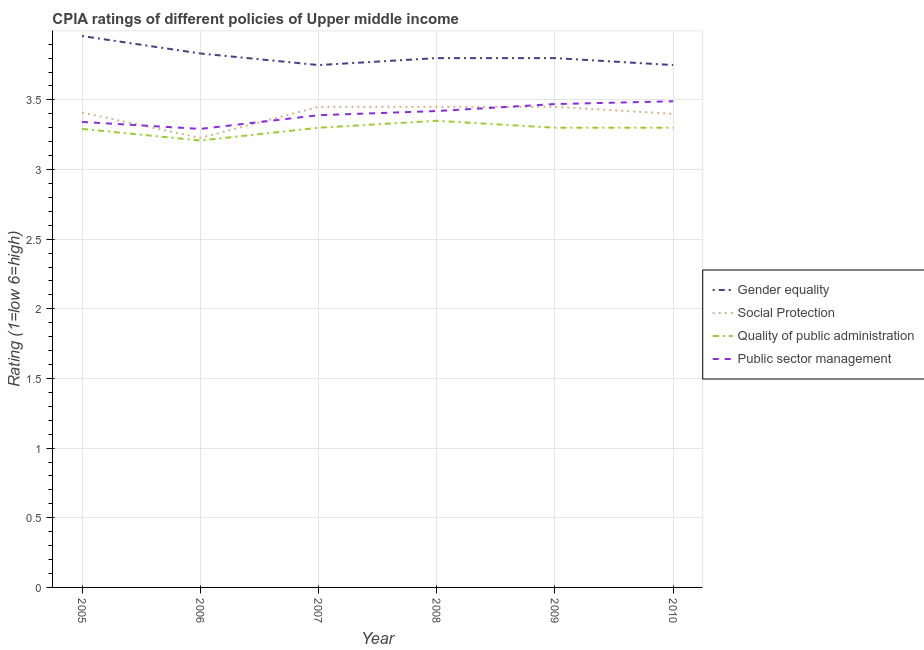Does the line corresponding to cpia rating of quality of public administration intersect with the line corresponding to cpia rating of gender equality?
Offer a terse response. No. What is the cpia rating of public sector management in 2007?
Provide a short and direct response. 3.39. Across all years, what is the maximum cpia rating of public sector management?
Your response must be concise. 3.49. Across all years, what is the minimum cpia rating of public sector management?
Give a very brief answer. 3.29. In which year was the cpia rating of quality of public administration maximum?
Your response must be concise. 2008. What is the total cpia rating of social protection in the graph?
Your response must be concise. 20.39. What is the difference between the cpia rating of gender equality in 2007 and the cpia rating of public sector management in 2006?
Your answer should be compact. 0.46. What is the average cpia rating of gender equality per year?
Provide a succinct answer. 3.82. In the year 2005, what is the difference between the cpia rating of gender equality and cpia rating of public sector management?
Provide a short and direct response. 0.62. In how many years, is the cpia rating of quality of public administration greater than 1.4?
Ensure brevity in your answer.  6. What is the ratio of the cpia rating of gender equality in 2005 to that in 2006?
Offer a terse response. 1.03. Is the cpia rating of gender equality in 2006 less than that in 2009?
Provide a short and direct response. No. Is the difference between the cpia rating of gender equality in 2006 and 2010 greater than the difference between the cpia rating of quality of public administration in 2006 and 2010?
Your answer should be very brief. Yes. What is the difference between the highest and the second highest cpia rating of gender equality?
Your response must be concise. 0.12. What is the difference between the highest and the lowest cpia rating of gender equality?
Keep it short and to the point. 0.21. In how many years, is the cpia rating of quality of public administration greater than the average cpia rating of quality of public administration taken over all years?
Keep it short and to the point. 5. Is the sum of the cpia rating of public sector management in 2005 and 2007 greater than the maximum cpia rating of quality of public administration across all years?
Your answer should be very brief. Yes. Is it the case that in every year, the sum of the cpia rating of gender equality and cpia rating of social protection is greater than the cpia rating of quality of public administration?
Keep it short and to the point. Yes. Is the cpia rating of public sector management strictly less than the cpia rating of quality of public administration over the years?
Ensure brevity in your answer.  No. Are the values on the major ticks of Y-axis written in scientific E-notation?
Offer a very short reply. No. Does the graph contain grids?
Provide a succinct answer. Yes. What is the title of the graph?
Make the answer very short. CPIA ratings of different policies of Upper middle income. Does "Natural Gas" appear as one of the legend labels in the graph?
Provide a short and direct response. No. What is the Rating (1=low 6=high) of Gender equality in 2005?
Give a very brief answer. 3.96. What is the Rating (1=low 6=high) of Social Protection in 2005?
Keep it short and to the point. 3.41. What is the Rating (1=low 6=high) of Quality of public administration in 2005?
Provide a short and direct response. 3.29. What is the Rating (1=low 6=high) of Public sector management in 2005?
Your response must be concise. 3.34. What is the Rating (1=low 6=high) in Gender equality in 2006?
Your answer should be compact. 3.83. What is the Rating (1=low 6=high) in Social Protection in 2006?
Give a very brief answer. 3.23. What is the Rating (1=low 6=high) of Quality of public administration in 2006?
Make the answer very short. 3.21. What is the Rating (1=low 6=high) in Public sector management in 2006?
Keep it short and to the point. 3.29. What is the Rating (1=low 6=high) in Gender equality in 2007?
Your response must be concise. 3.75. What is the Rating (1=low 6=high) of Social Protection in 2007?
Your answer should be compact. 3.45. What is the Rating (1=low 6=high) in Public sector management in 2007?
Make the answer very short. 3.39. What is the Rating (1=low 6=high) of Social Protection in 2008?
Offer a very short reply. 3.45. What is the Rating (1=low 6=high) of Quality of public administration in 2008?
Keep it short and to the point. 3.35. What is the Rating (1=low 6=high) of Public sector management in 2008?
Your response must be concise. 3.42. What is the Rating (1=low 6=high) of Social Protection in 2009?
Offer a terse response. 3.45. What is the Rating (1=low 6=high) in Quality of public administration in 2009?
Ensure brevity in your answer.  3.3. What is the Rating (1=low 6=high) of Public sector management in 2009?
Provide a short and direct response. 3.47. What is the Rating (1=low 6=high) of Gender equality in 2010?
Provide a short and direct response. 3.75. What is the Rating (1=low 6=high) in Social Protection in 2010?
Your answer should be compact. 3.4. What is the Rating (1=low 6=high) of Public sector management in 2010?
Your answer should be very brief. 3.49. Across all years, what is the maximum Rating (1=low 6=high) of Gender equality?
Offer a terse response. 3.96. Across all years, what is the maximum Rating (1=low 6=high) of Social Protection?
Make the answer very short. 3.45. Across all years, what is the maximum Rating (1=low 6=high) in Quality of public administration?
Offer a very short reply. 3.35. Across all years, what is the maximum Rating (1=low 6=high) in Public sector management?
Make the answer very short. 3.49. Across all years, what is the minimum Rating (1=low 6=high) of Gender equality?
Your answer should be very brief. 3.75. Across all years, what is the minimum Rating (1=low 6=high) of Social Protection?
Keep it short and to the point. 3.23. Across all years, what is the minimum Rating (1=low 6=high) in Quality of public administration?
Make the answer very short. 3.21. Across all years, what is the minimum Rating (1=low 6=high) of Public sector management?
Give a very brief answer. 3.29. What is the total Rating (1=low 6=high) in Gender equality in the graph?
Make the answer very short. 22.89. What is the total Rating (1=low 6=high) of Social Protection in the graph?
Ensure brevity in your answer.  20.39. What is the total Rating (1=low 6=high) in Quality of public administration in the graph?
Provide a succinct answer. 19.75. What is the total Rating (1=low 6=high) of Public sector management in the graph?
Your response must be concise. 20.4. What is the difference between the Rating (1=low 6=high) of Social Protection in 2005 and that in 2006?
Offer a terse response. 0.18. What is the difference between the Rating (1=low 6=high) of Quality of public administration in 2005 and that in 2006?
Provide a short and direct response. 0.08. What is the difference between the Rating (1=low 6=high) of Gender equality in 2005 and that in 2007?
Provide a short and direct response. 0.21. What is the difference between the Rating (1=low 6=high) in Social Protection in 2005 and that in 2007?
Provide a succinct answer. -0.04. What is the difference between the Rating (1=low 6=high) of Quality of public administration in 2005 and that in 2007?
Provide a succinct answer. -0.01. What is the difference between the Rating (1=low 6=high) of Public sector management in 2005 and that in 2007?
Make the answer very short. -0.05. What is the difference between the Rating (1=low 6=high) of Gender equality in 2005 and that in 2008?
Provide a succinct answer. 0.16. What is the difference between the Rating (1=low 6=high) of Social Protection in 2005 and that in 2008?
Make the answer very short. -0.04. What is the difference between the Rating (1=low 6=high) of Quality of public administration in 2005 and that in 2008?
Provide a succinct answer. -0.06. What is the difference between the Rating (1=low 6=high) of Public sector management in 2005 and that in 2008?
Provide a succinct answer. -0.08. What is the difference between the Rating (1=low 6=high) of Gender equality in 2005 and that in 2009?
Give a very brief answer. 0.16. What is the difference between the Rating (1=low 6=high) in Social Protection in 2005 and that in 2009?
Ensure brevity in your answer.  -0.04. What is the difference between the Rating (1=low 6=high) of Quality of public administration in 2005 and that in 2009?
Make the answer very short. -0.01. What is the difference between the Rating (1=low 6=high) of Public sector management in 2005 and that in 2009?
Your answer should be compact. -0.13. What is the difference between the Rating (1=low 6=high) of Gender equality in 2005 and that in 2010?
Provide a short and direct response. 0.21. What is the difference between the Rating (1=low 6=high) in Social Protection in 2005 and that in 2010?
Give a very brief answer. 0.01. What is the difference between the Rating (1=low 6=high) of Quality of public administration in 2005 and that in 2010?
Your response must be concise. -0.01. What is the difference between the Rating (1=low 6=high) of Public sector management in 2005 and that in 2010?
Offer a very short reply. -0.15. What is the difference between the Rating (1=low 6=high) in Gender equality in 2006 and that in 2007?
Give a very brief answer. 0.08. What is the difference between the Rating (1=low 6=high) of Social Protection in 2006 and that in 2007?
Provide a succinct answer. -0.22. What is the difference between the Rating (1=low 6=high) of Quality of public administration in 2006 and that in 2007?
Ensure brevity in your answer.  -0.09. What is the difference between the Rating (1=low 6=high) in Public sector management in 2006 and that in 2007?
Provide a succinct answer. -0.1. What is the difference between the Rating (1=low 6=high) of Social Protection in 2006 and that in 2008?
Keep it short and to the point. -0.22. What is the difference between the Rating (1=low 6=high) in Quality of public administration in 2006 and that in 2008?
Your answer should be very brief. -0.14. What is the difference between the Rating (1=low 6=high) in Public sector management in 2006 and that in 2008?
Offer a terse response. -0.13. What is the difference between the Rating (1=low 6=high) of Social Protection in 2006 and that in 2009?
Your answer should be compact. -0.22. What is the difference between the Rating (1=low 6=high) of Quality of public administration in 2006 and that in 2009?
Make the answer very short. -0.09. What is the difference between the Rating (1=low 6=high) in Public sector management in 2006 and that in 2009?
Ensure brevity in your answer.  -0.18. What is the difference between the Rating (1=low 6=high) in Gender equality in 2006 and that in 2010?
Give a very brief answer. 0.08. What is the difference between the Rating (1=low 6=high) of Social Protection in 2006 and that in 2010?
Provide a short and direct response. -0.17. What is the difference between the Rating (1=low 6=high) of Quality of public administration in 2006 and that in 2010?
Ensure brevity in your answer.  -0.09. What is the difference between the Rating (1=low 6=high) in Public sector management in 2006 and that in 2010?
Keep it short and to the point. -0.2. What is the difference between the Rating (1=low 6=high) in Quality of public administration in 2007 and that in 2008?
Offer a terse response. -0.05. What is the difference between the Rating (1=low 6=high) in Public sector management in 2007 and that in 2008?
Provide a short and direct response. -0.03. What is the difference between the Rating (1=low 6=high) in Public sector management in 2007 and that in 2009?
Keep it short and to the point. -0.08. What is the difference between the Rating (1=low 6=high) of Gender equality in 2008 and that in 2009?
Provide a short and direct response. 0. What is the difference between the Rating (1=low 6=high) of Social Protection in 2008 and that in 2009?
Offer a terse response. 0. What is the difference between the Rating (1=low 6=high) in Quality of public administration in 2008 and that in 2009?
Your answer should be very brief. 0.05. What is the difference between the Rating (1=low 6=high) in Public sector management in 2008 and that in 2009?
Offer a very short reply. -0.05. What is the difference between the Rating (1=low 6=high) of Gender equality in 2008 and that in 2010?
Your response must be concise. 0.05. What is the difference between the Rating (1=low 6=high) of Social Protection in 2008 and that in 2010?
Provide a short and direct response. 0.05. What is the difference between the Rating (1=low 6=high) in Quality of public administration in 2008 and that in 2010?
Provide a succinct answer. 0.05. What is the difference between the Rating (1=low 6=high) of Public sector management in 2008 and that in 2010?
Offer a very short reply. -0.07. What is the difference between the Rating (1=low 6=high) in Public sector management in 2009 and that in 2010?
Your response must be concise. -0.02. What is the difference between the Rating (1=low 6=high) in Gender equality in 2005 and the Rating (1=low 6=high) in Social Protection in 2006?
Make the answer very short. 0.73. What is the difference between the Rating (1=low 6=high) of Social Protection in 2005 and the Rating (1=low 6=high) of Quality of public administration in 2006?
Offer a terse response. 0.2. What is the difference between the Rating (1=low 6=high) of Social Protection in 2005 and the Rating (1=low 6=high) of Public sector management in 2006?
Make the answer very short. 0.12. What is the difference between the Rating (1=low 6=high) of Gender equality in 2005 and the Rating (1=low 6=high) of Social Protection in 2007?
Ensure brevity in your answer.  0.51. What is the difference between the Rating (1=low 6=high) of Gender equality in 2005 and the Rating (1=low 6=high) of Quality of public administration in 2007?
Your answer should be compact. 0.66. What is the difference between the Rating (1=low 6=high) in Gender equality in 2005 and the Rating (1=low 6=high) in Public sector management in 2007?
Provide a succinct answer. 0.57. What is the difference between the Rating (1=low 6=high) in Social Protection in 2005 and the Rating (1=low 6=high) in Quality of public administration in 2007?
Your response must be concise. 0.11. What is the difference between the Rating (1=low 6=high) in Social Protection in 2005 and the Rating (1=low 6=high) in Public sector management in 2007?
Give a very brief answer. 0.02. What is the difference between the Rating (1=low 6=high) of Quality of public administration in 2005 and the Rating (1=low 6=high) of Public sector management in 2007?
Provide a succinct answer. -0.1. What is the difference between the Rating (1=low 6=high) of Gender equality in 2005 and the Rating (1=low 6=high) of Social Protection in 2008?
Your response must be concise. 0.51. What is the difference between the Rating (1=low 6=high) in Gender equality in 2005 and the Rating (1=low 6=high) in Quality of public administration in 2008?
Make the answer very short. 0.61. What is the difference between the Rating (1=low 6=high) in Gender equality in 2005 and the Rating (1=low 6=high) in Public sector management in 2008?
Ensure brevity in your answer.  0.54. What is the difference between the Rating (1=low 6=high) of Social Protection in 2005 and the Rating (1=low 6=high) of Quality of public administration in 2008?
Your answer should be very brief. 0.06. What is the difference between the Rating (1=low 6=high) of Social Protection in 2005 and the Rating (1=low 6=high) of Public sector management in 2008?
Make the answer very short. -0.01. What is the difference between the Rating (1=low 6=high) in Quality of public administration in 2005 and the Rating (1=low 6=high) in Public sector management in 2008?
Provide a succinct answer. -0.13. What is the difference between the Rating (1=low 6=high) in Gender equality in 2005 and the Rating (1=low 6=high) in Social Protection in 2009?
Give a very brief answer. 0.51. What is the difference between the Rating (1=low 6=high) of Gender equality in 2005 and the Rating (1=low 6=high) of Quality of public administration in 2009?
Your response must be concise. 0.66. What is the difference between the Rating (1=low 6=high) of Gender equality in 2005 and the Rating (1=low 6=high) of Public sector management in 2009?
Provide a succinct answer. 0.49. What is the difference between the Rating (1=low 6=high) of Social Protection in 2005 and the Rating (1=low 6=high) of Quality of public administration in 2009?
Your answer should be compact. 0.11. What is the difference between the Rating (1=low 6=high) of Social Protection in 2005 and the Rating (1=low 6=high) of Public sector management in 2009?
Provide a short and direct response. -0.06. What is the difference between the Rating (1=low 6=high) of Quality of public administration in 2005 and the Rating (1=low 6=high) of Public sector management in 2009?
Offer a terse response. -0.18. What is the difference between the Rating (1=low 6=high) of Gender equality in 2005 and the Rating (1=low 6=high) of Social Protection in 2010?
Give a very brief answer. 0.56. What is the difference between the Rating (1=low 6=high) of Gender equality in 2005 and the Rating (1=low 6=high) of Quality of public administration in 2010?
Offer a very short reply. 0.66. What is the difference between the Rating (1=low 6=high) in Gender equality in 2005 and the Rating (1=low 6=high) in Public sector management in 2010?
Offer a terse response. 0.47. What is the difference between the Rating (1=low 6=high) in Social Protection in 2005 and the Rating (1=low 6=high) in Quality of public administration in 2010?
Make the answer very short. 0.11. What is the difference between the Rating (1=low 6=high) of Social Protection in 2005 and the Rating (1=low 6=high) of Public sector management in 2010?
Offer a terse response. -0.08. What is the difference between the Rating (1=low 6=high) in Quality of public administration in 2005 and the Rating (1=low 6=high) in Public sector management in 2010?
Provide a succinct answer. -0.2. What is the difference between the Rating (1=low 6=high) in Gender equality in 2006 and the Rating (1=low 6=high) in Social Protection in 2007?
Offer a very short reply. 0.38. What is the difference between the Rating (1=low 6=high) in Gender equality in 2006 and the Rating (1=low 6=high) in Quality of public administration in 2007?
Make the answer very short. 0.53. What is the difference between the Rating (1=low 6=high) of Gender equality in 2006 and the Rating (1=low 6=high) of Public sector management in 2007?
Your response must be concise. 0.44. What is the difference between the Rating (1=low 6=high) in Social Protection in 2006 and the Rating (1=low 6=high) in Quality of public administration in 2007?
Provide a succinct answer. -0.07. What is the difference between the Rating (1=low 6=high) of Social Protection in 2006 and the Rating (1=low 6=high) of Public sector management in 2007?
Give a very brief answer. -0.16. What is the difference between the Rating (1=low 6=high) in Quality of public administration in 2006 and the Rating (1=low 6=high) in Public sector management in 2007?
Your response must be concise. -0.18. What is the difference between the Rating (1=low 6=high) in Gender equality in 2006 and the Rating (1=low 6=high) in Social Protection in 2008?
Provide a short and direct response. 0.38. What is the difference between the Rating (1=low 6=high) in Gender equality in 2006 and the Rating (1=low 6=high) in Quality of public administration in 2008?
Provide a short and direct response. 0.48. What is the difference between the Rating (1=low 6=high) of Gender equality in 2006 and the Rating (1=low 6=high) of Public sector management in 2008?
Your answer should be very brief. 0.41. What is the difference between the Rating (1=low 6=high) of Social Protection in 2006 and the Rating (1=low 6=high) of Quality of public administration in 2008?
Provide a short and direct response. -0.12. What is the difference between the Rating (1=low 6=high) in Social Protection in 2006 and the Rating (1=low 6=high) in Public sector management in 2008?
Your response must be concise. -0.19. What is the difference between the Rating (1=low 6=high) of Quality of public administration in 2006 and the Rating (1=low 6=high) of Public sector management in 2008?
Keep it short and to the point. -0.21. What is the difference between the Rating (1=low 6=high) of Gender equality in 2006 and the Rating (1=low 6=high) of Social Protection in 2009?
Provide a short and direct response. 0.38. What is the difference between the Rating (1=low 6=high) in Gender equality in 2006 and the Rating (1=low 6=high) in Quality of public administration in 2009?
Your answer should be compact. 0.53. What is the difference between the Rating (1=low 6=high) in Gender equality in 2006 and the Rating (1=low 6=high) in Public sector management in 2009?
Offer a very short reply. 0.36. What is the difference between the Rating (1=low 6=high) of Social Protection in 2006 and the Rating (1=low 6=high) of Quality of public administration in 2009?
Keep it short and to the point. -0.07. What is the difference between the Rating (1=low 6=high) in Social Protection in 2006 and the Rating (1=low 6=high) in Public sector management in 2009?
Ensure brevity in your answer.  -0.24. What is the difference between the Rating (1=low 6=high) in Quality of public administration in 2006 and the Rating (1=low 6=high) in Public sector management in 2009?
Ensure brevity in your answer.  -0.26. What is the difference between the Rating (1=low 6=high) in Gender equality in 2006 and the Rating (1=low 6=high) in Social Protection in 2010?
Make the answer very short. 0.43. What is the difference between the Rating (1=low 6=high) of Gender equality in 2006 and the Rating (1=low 6=high) of Quality of public administration in 2010?
Ensure brevity in your answer.  0.53. What is the difference between the Rating (1=low 6=high) in Gender equality in 2006 and the Rating (1=low 6=high) in Public sector management in 2010?
Your response must be concise. 0.34. What is the difference between the Rating (1=low 6=high) in Social Protection in 2006 and the Rating (1=low 6=high) in Quality of public administration in 2010?
Provide a short and direct response. -0.07. What is the difference between the Rating (1=low 6=high) in Social Protection in 2006 and the Rating (1=low 6=high) in Public sector management in 2010?
Give a very brief answer. -0.26. What is the difference between the Rating (1=low 6=high) of Quality of public administration in 2006 and the Rating (1=low 6=high) of Public sector management in 2010?
Provide a short and direct response. -0.28. What is the difference between the Rating (1=low 6=high) of Gender equality in 2007 and the Rating (1=low 6=high) of Quality of public administration in 2008?
Your answer should be very brief. 0.4. What is the difference between the Rating (1=low 6=high) of Gender equality in 2007 and the Rating (1=low 6=high) of Public sector management in 2008?
Ensure brevity in your answer.  0.33. What is the difference between the Rating (1=low 6=high) in Social Protection in 2007 and the Rating (1=low 6=high) in Quality of public administration in 2008?
Your response must be concise. 0.1. What is the difference between the Rating (1=low 6=high) of Social Protection in 2007 and the Rating (1=low 6=high) of Public sector management in 2008?
Keep it short and to the point. 0.03. What is the difference between the Rating (1=low 6=high) of Quality of public administration in 2007 and the Rating (1=low 6=high) of Public sector management in 2008?
Offer a very short reply. -0.12. What is the difference between the Rating (1=low 6=high) of Gender equality in 2007 and the Rating (1=low 6=high) of Quality of public administration in 2009?
Your answer should be compact. 0.45. What is the difference between the Rating (1=low 6=high) of Gender equality in 2007 and the Rating (1=low 6=high) of Public sector management in 2009?
Provide a short and direct response. 0.28. What is the difference between the Rating (1=low 6=high) of Social Protection in 2007 and the Rating (1=low 6=high) of Quality of public administration in 2009?
Your answer should be compact. 0.15. What is the difference between the Rating (1=low 6=high) in Social Protection in 2007 and the Rating (1=low 6=high) in Public sector management in 2009?
Give a very brief answer. -0.02. What is the difference between the Rating (1=low 6=high) in Quality of public administration in 2007 and the Rating (1=low 6=high) in Public sector management in 2009?
Give a very brief answer. -0.17. What is the difference between the Rating (1=low 6=high) in Gender equality in 2007 and the Rating (1=low 6=high) in Social Protection in 2010?
Offer a terse response. 0.35. What is the difference between the Rating (1=low 6=high) of Gender equality in 2007 and the Rating (1=low 6=high) of Quality of public administration in 2010?
Provide a succinct answer. 0.45. What is the difference between the Rating (1=low 6=high) of Gender equality in 2007 and the Rating (1=low 6=high) of Public sector management in 2010?
Your answer should be very brief. 0.26. What is the difference between the Rating (1=low 6=high) of Social Protection in 2007 and the Rating (1=low 6=high) of Public sector management in 2010?
Keep it short and to the point. -0.04. What is the difference between the Rating (1=low 6=high) of Quality of public administration in 2007 and the Rating (1=low 6=high) of Public sector management in 2010?
Make the answer very short. -0.19. What is the difference between the Rating (1=low 6=high) in Gender equality in 2008 and the Rating (1=low 6=high) in Social Protection in 2009?
Give a very brief answer. 0.35. What is the difference between the Rating (1=low 6=high) in Gender equality in 2008 and the Rating (1=low 6=high) in Quality of public administration in 2009?
Offer a terse response. 0.5. What is the difference between the Rating (1=low 6=high) of Gender equality in 2008 and the Rating (1=low 6=high) of Public sector management in 2009?
Your answer should be very brief. 0.33. What is the difference between the Rating (1=low 6=high) in Social Protection in 2008 and the Rating (1=low 6=high) in Quality of public administration in 2009?
Provide a succinct answer. 0.15. What is the difference between the Rating (1=low 6=high) in Social Protection in 2008 and the Rating (1=low 6=high) in Public sector management in 2009?
Provide a succinct answer. -0.02. What is the difference between the Rating (1=low 6=high) of Quality of public administration in 2008 and the Rating (1=low 6=high) of Public sector management in 2009?
Make the answer very short. -0.12. What is the difference between the Rating (1=low 6=high) in Gender equality in 2008 and the Rating (1=low 6=high) in Social Protection in 2010?
Offer a very short reply. 0.4. What is the difference between the Rating (1=low 6=high) in Gender equality in 2008 and the Rating (1=low 6=high) in Quality of public administration in 2010?
Provide a short and direct response. 0.5. What is the difference between the Rating (1=low 6=high) in Gender equality in 2008 and the Rating (1=low 6=high) in Public sector management in 2010?
Your response must be concise. 0.31. What is the difference between the Rating (1=low 6=high) of Social Protection in 2008 and the Rating (1=low 6=high) of Quality of public administration in 2010?
Keep it short and to the point. 0.15. What is the difference between the Rating (1=low 6=high) of Social Protection in 2008 and the Rating (1=low 6=high) of Public sector management in 2010?
Provide a succinct answer. -0.04. What is the difference between the Rating (1=low 6=high) in Quality of public administration in 2008 and the Rating (1=low 6=high) in Public sector management in 2010?
Your answer should be very brief. -0.14. What is the difference between the Rating (1=low 6=high) in Gender equality in 2009 and the Rating (1=low 6=high) in Social Protection in 2010?
Ensure brevity in your answer.  0.4. What is the difference between the Rating (1=low 6=high) in Gender equality in 2009 and the Rating (1=low 6=high) in Public sector management in 2010?
Keep it short and to the point. 0.31. What is the difference between the Rating (1=low 6=high) of Social Protection in 2009 and the Rating (1=low 6=high) of Quality of public administration in 2010?
Your answer should be very brief. 0.15. What is the difference between the Rating (1=low 6=high) in Social Protection in 2009 and the Rating (1=low 6=high) in Public sector management in 2010?
Make the answer very short. -0.04. What is the difference between the Rating (1=low 6=high) in Quality of public administration in 2009 and the Rating (1=low 6=high) in Public sector management in 2010?
Give a very brief answer. -0.19. What is the average Rating (1=low 6=high) in Gender equality per year?
Provide a short and direct response. 3.82. What is the average Rating (1=low 6=high) in Social Protection per year?
Your answer should be compact. 3.4. What is the average Rating (1=low 6=high) of Quality of public administration per year?
Ensure brevity in your answer.  3.29. What is the average Rating (1=low 6=high) in Public sector management per year?
Your answer should be very brief. 3.4. In the year 2005, what is the difference between the Rating (1=low 6=high) of Gender equality and Rating (1=low 6=high) of Social Protection?
Give a very brief answer. 0.55. In the year 2005, what is the difference between the Rating (1=low 6=high) in Gender equality and Rating (1=low 6=high) in Public sector management?
Provide a succinct answer. 0.62. In the year 2005, what is the difference between the Rating (1=low 6=high) in Social Protection and Rating (1=low 6=high) in Quality of public administration?
Provide a short and direct response. 0.12. In the year 2005, what is the difference between the Rating (1=low 6=high) of Social Protection and Rating (1=low 6=high) of Public sector management?
Ensure brevity in your answer.  0.07. In the year 2006, what is the difference between the Rating (1=low 6=high) of Gender equality and Rating (1=low 6=high) of Social Protection?
Ensure brevity in your answer.  0.61. In the year 2006, what is the difference between the Rating (1=low 6=high) in Gender equality and Rating (1=low 6=high) in Public sector management?
Ensure brevity in your answer.  0.54. In the year 2006, what is the difference between the Rating (1=low 6=high) of Social Protection and Rating (1=low 6=high) of Quality of public administration?
Give a very brief answer. 0.02. In the year 2006, what is the difference between the Rating (1=low 6=high) in Social Protection and Rating (1=low 6=high) in Public sector management?
Provide a succinct answer. -0.06. In the year 2006, what is the difference between the Rating (1=low 6=high) of Quality of public administration and Rating (1=low 6=high) of Public sector management?
Keep it short and to the point. -0.08. In the year 2007, what is the difference between the Rating (1=low 6=high) of Gender equality and Rating (1=low 6=high) of Social Protection?
Make the answer very short. 0.3. In the year 2007, what is the difference between the Rating (1=low 6=high) in Gender equality and Rating (1=low 6=high) in Quality of public administration?
Your answer should be compact. 0.45. In the year 2007, what is the difference between the Rating (1=low 6=high) in Gender equality and Rating (1=low 6=high) in Public sector management?
Your answer should be very brief. 0.36. In the year 2007, what is the difference between the Rating (1=low 6=high) in Social Protection and Rating (1=low 6=high) in Public sector management?
Make the answer very short. 0.06. In the year 2007, what is the difference between the Rating (1=low 6=high) of Quality of public administration and Rating (1=low 6=high) of Public sector management?
Provide a succinct answer. -0.09. In the year 2008, what is the difference between the Rating (1=low 6=high) of Gender equality and Rating (1=low 6=high) of Quality of public administration?
Offer a terse response. 0.45. In the year 2008, what is the difference between the Rating (1=low 6=high) of Gender equality and Rating (1=low 6=high) of Public sector management?
Provide a short and direct response. 0.38. In the year 2008, what is the difference between the Rating (1=low 6=high) in Quality of public administration and Rating (1=low 6=high) in Public sector management?
Offer a terse response. -0.07. In the year 2009, what is the difference between the Rating (1=low 6=high) of Gender equality and Rating (1=low 6=high) of Quality of public administration?
Make the answer very short. 0.5. In the year 2009, what is the difference between the Rating (1=low 6=high) in Gender equality and Rating (1=low 6=high) in Public sector management?
Your answer should be very brief. 0.33. In the year 2009, what is the difference between the Rating (1=low 6=high) of Social Protection and Rating (1=low 6=high) of Public sector management?
Your response must be concise. -0.02. In the year 2009, what is the difference between the Rating (1=low 6=high) of Quality of public administration and Rating (1=low 6=high) of Public sector management?
Provide a short and direct response. -0.17. In the year 2010, what is the difference between the Rating (1=low 6=high) in Gender equality and Rating (1=low 6=high) in Quality of public administration?
Make the answer very short. 0.45. In the year 2010, what is the difference between the Rating (1=low 6=high) of Gender equality and Rating (1=low 6=high) of Public sector management?
Your answer should be compact. 0.26. In the year 2010, what is the difference between the Rating (1=low 6=high) in Social Protection and Rating (1=low 6=high) in Quality of public administration?
Provide a succinct answer. 0.1. In the year 2010, what is the difference between the Rating (1=low 6=high) of Social Protection and Rating (1=low 6=high) of Public sector management?
Your answer should be very brief. -0.09. In the year 2010, what is the difference between the Rating (1=low 6=high) of Quality of public administration and Rating (1=low 6=high) of Public sector management?
Your response must be concise. -0.19. What is the ratio of the Rating (1=low 6=high) of Gender equality in 2005 to that in 2006?
Provide a short and direct response. 1.03. What is the ratio of the Rating (1=low 6=high) of Social Protection in 2005 to that in 2006?
Your answer should be compact. 1.06. What is the ratio of the Rating (1=low 6=high) of Quality of public administration in 2005 to that in 2006?
Give a very brief answer. 1.03. What is the ratio of the Rating (1=low 6=high) in Public sector management in 2005 to that in 2006?
Provide a succinct answer. 1.02. What is the ratio of the Rating (1=low 6=high) of Gender equality in 2005 to that in 2007?
Provide a succinct answer. 1.06. What is the ratio of the Rating (1=low 6=high) in Public sector management in 2005 to that in 2007?
Keep it short and to the point. 0.99. What is the ratio of the Rating (1=low 6=high) in Gender equality in 2005 to that in 2008?
Give a very brief answer. 1.04. What is the ratio of the Rating (1=low 6=high) in Social Protection in 2005 to that in 2008?
Make the answer very short. 0.99. What is the ratio of the Rating (1=low 6=high) of Quality of public administration in 2005 to that in 2008?
Give a very brief answer. 0.98. What is the ratio of the Rating (1=low 6=high) in Public sector management in 2005 to that in 2008?
Your answer should be very brief. 0.98. What is the ratio of the Rating (1=low 6=high) in Gender equality in 2005 to that in 2009?
Give a very brief answer. 1.04. What is the ratio of the Rating (1=low 6=high) of Social Protection in 2005 to that in 2009?
Your answer should be very brief. 0.99. What is the ratio of the Rating (1=low 6=high) of Public sector management in 2005 to that in 2009?
Provide a succinct answer. 0.96. What is the ratio of the Rating (1=low 6=high) in Gender equality in 2005 to that in 2010?
Keep it short and to the point. 1.06. What is the ratio of the Rating (1=low 6=high) of Social Protection in 2005 to that in 2010?
Make the answer very short. 1. What is the ratio of the Rating (1=low 6=high) of Public sector management in 2005 to that in 2010?
Your answer should be very brief. 0.96. What is the ratio of the Rating (1=low 6=high) of Gender equality in 2006 to that in 2007?
Offer a very short reply. 1.02. What is the ratio of the Rating (1=low 6=high) in Social Protection in 2006 to that in 2007?
Offer a terse response. 0.94. What is the ratio of the Rating (1=low 6=high) of Quality of public administration in 2006 to that in 2007?
Offer a terse response. 0.97. What is the ratio of the Rating (1=low 6=high) of Gender equality in 2006 to that in 2008?
Provide a succinct answer. 1.01. What is the ratio of the Rating (1=low 6=high) of Social Protection in 2006 to that in 2008?
Your answer should be compact. 0.94. What is the ratio of the Rating (1=low 6=high) of Quality of public administration in 2006 to that in 2008?
Give a very brief answer. 0.96. What is the ratio of the Rating (1=low 6=high) of Public sector management in 2006 to that in 2008?
Your response must be concise. 0.96. What is the ratio of the Rating (1=low 6=high) of Gender equality in 2006 to that in 2009?
Your answer should be very brief. 1.01. What is the ratio of the Rating (1=low 6=high) of Social Protection in 2006 to that in 2009?
Keep it short and to the point. 0.94. What is the ratio of the Rating (1=low 6=high) of Quality of public administration in 2006 to that in 2009?
Make the answer very short. 0.97. What is the ratio of the Rating (1=low 6=high) of Public sector management in 2006 to that in 2009?
Keep it short and to the point. 0.95. What is the ratio of the Rating (1=low 6=high) of Gender equality in 2006 to that in 2010?
Make the answer very short. 1.02. What is the ratio of the Rating (1=low 6=high) in Social Protection in 2006 to that in 2010?
Your answer should be very brief. 0.95. What is the ratio of the Rating (1=low 6=high) in Quality of public administration in 2006 to that in 2010?
Ensure brevity in your answer.  0.97. What is the ratio of the Rating (1=low 6=high) of Public sector management in 2006 to that in 2010?
Offer a very short reply. 0.94. What is the ratio of the Rating (1=low 6=high) of Gender equality in 2007 to that in 2008?
Make the answer very short. 0.99. What is the ratio of the Rating (1=low 6=high) of Social Protection in 2007 to that in 2008?
Your answer should be very brief. 1. What is the ratio of the Rating (1=low 6=high) in Quality of public administration in 2007 to that in 2008?
Offer a very short reply. 0.99. What is the ratio of the Rating (1=low 6=high) in Public sector management in 2007 to that in 2008?
Make the answer very short. 0.99. What is the ratio of the Rating (1=low 6=high) in Social Protection in 2007 to that in 2009?
Offer a very short reply. 1. What is the ratio of the Rating (1=low 6=high) of Quality of public administration in 2007 to that in 2009?
Your answer should be very brief. 1. What is the ratio of the Rating (1=low 6=high) in Public sector management in 2007 to that in 2009?
Offer a very short reply. 0.98. What is the ratio of the Rating (1=low 6=high) in Social Protection in 2007 to that in 2010?
Keep it short and to the point. 1.01. What is the ratio of the Rating (1=low 6=high) of Quality of public administration in 2007 to that in 2010?
Ensure brevity in your answer.  1. What is the ratio of the Rating (1=low 6=high) in Public sector management in 2007 to that in 2010?
Your response must be concise. 0.97. What is the ratio of the Rating (1=low 6=high) in Gender equality in 2008 to that in 2009?
Ensure brevity in your answer.  1. What is the ratio of the Rating (1=low 6=high) of Quality of public administration in 2008 to that in 2009?
Ensure brevity in your answer.  1.02. What is the ratio of the Rating (1=low 6=high) of Public sector management in 2008 to that in 2009?
Ensure brevity in your answer.  0.99. What is the ratio of the Rating (1=low 6=high) in Gender equality in 2008 to that in 2010?
Offer a very short reply. 1.01. What is the ratio of the Rating (1=low 6=high) of Social Protection in 2008 to that in 2010?
Offer a terse response. 1.01. What is the ratio of the Rating (1=low 6=high) in Quality of public administration in 2008 to that in 2010?
Keep it short and to the point. 1.02. What is the ratio of the Rating (1=low 6=high) of Public sector management in 2008 to that in 2010?
Offer a terse response. 0.98. What is the ratio of the Rating (1=low 6=high) of Gender equality in 2009 to that in 2010?
Your answer should be very brief. 1.01. What is the ratio of the Rating (1=low 6=high) in Social Protection in 2009 to that in 2010?
Ensure brevity in your answer.  1.01. What is the difference between the highest and the second highest Rating (1=low 6=high) of Gender equality?
Make the answer very short. 0.12. What is the difference between the highest and the second highest Rating (1=low 6=high) of Social Protection?
Offer a terse response. 0. What is the difference between the highest and the second highest Rating (1=low 6=high) in Public sector management?
Your answer should be very brief. 0.02. What is the difference between the highest and the lowest Rating (1=low 6=high) in Gender equality?
Provide a succinct answer. 0.21. What is the difference between the highest and the lowest Rating (1=low 6=high) of Social Protection?
Your answer should be compact. 0.22. What is the difference between the highest and the lowest Rating (1=low 6=high) of Quality of public administration?
Provide a succinct answer. 0.14. What is the difference between the highest and the lowest Rating (1=low 6=high) in Public sector management?
Offer a terse response. 0.2. 